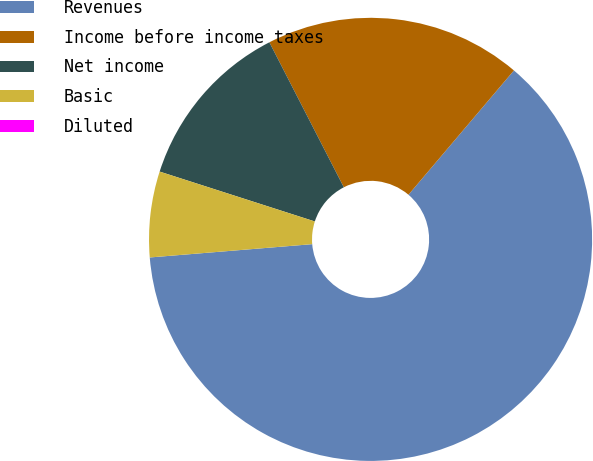Convert chart. <chart><loc_0><loc_0><loc_500><loc_500><pie_chart><fcel>Revenues<fcel>Income before income taxes<fcel>Net income<fcel>Basic<fcel>Diluted<nl><fcel>62.5%<fcel>18.75%<fcel>12.5%<fcel>6.25%<fcel>0.0%<nl></chart> 